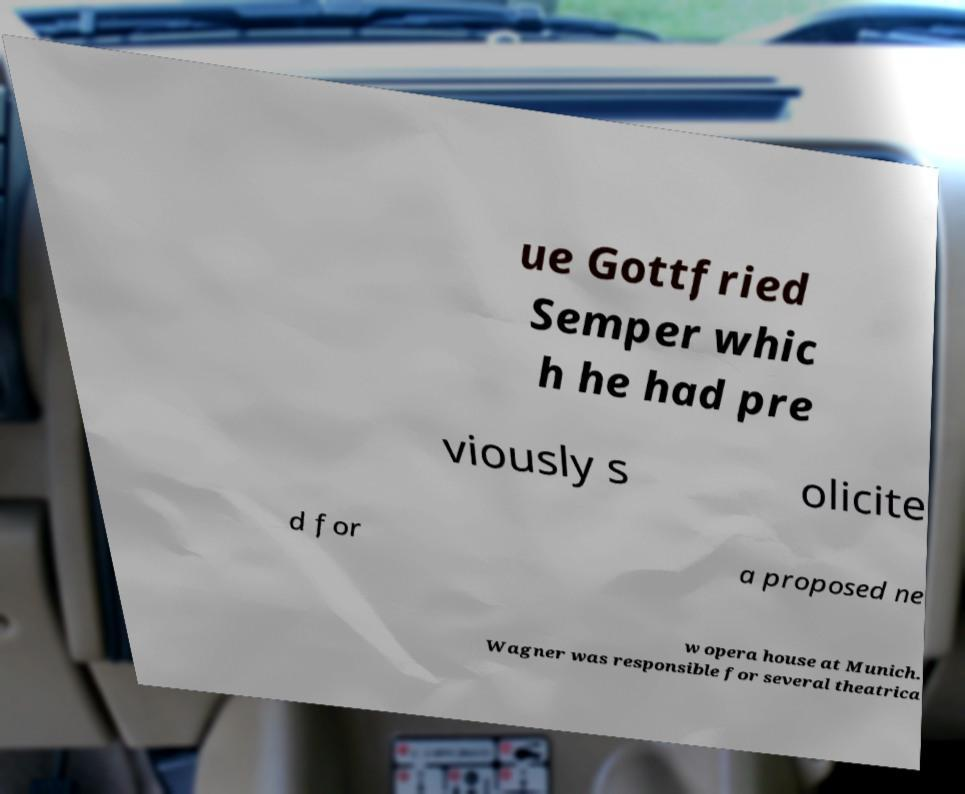I need the written content from this picture converted into text. Can you do that? ue Gottfried Semper whic h he had pre viously s olicite d for a proposed ne w opera house at Munich. Wagner was responsible for several theatrica 